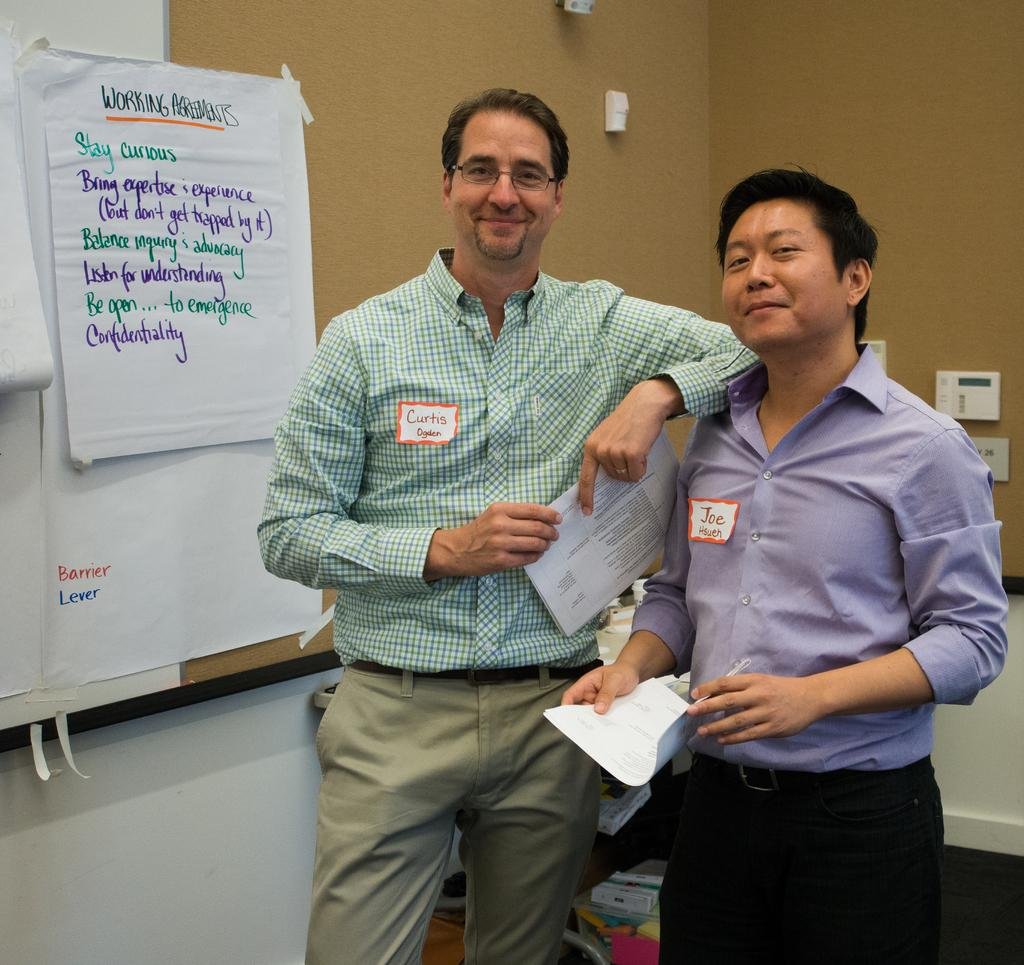How many people are in the image? There are two people standing in the image. What are the people holding? The people are holding papers. What can be seen in the background of the image? There are papers attached to a board and other objects visible in the background. Is there a representative holding an umbrella in the image? There is no representative or umbrella present in the image. 